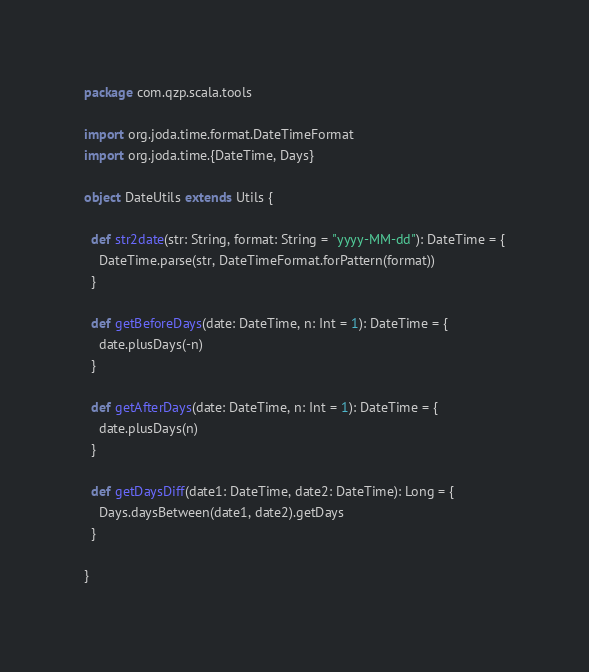Convert code to text. <code><loc_0><loc_0><loc_500><loc_500><_Scala_>package com.qzp.scala.tools

import org.joda.time.format.DateTimeFormat
import org.joda.time.{DateTime, Days}

object DateUtils extends Utils {

  def str2date(str: String, format: String = "yyyy-MM-dd"): DateTime = {
    DateTime.parse(str, DateTimeFormat.forPattern(format))
  }

  def getBeforeDays(date: DateTime, n: Int = 1): DateTime = {
    date.plusDays(-n)
  }

  def getAfterDays(date: DateTime, n: Int = 1): DateTime = {
    date.plusDays(n)
  }

  def getDaysDiff(date1: DateTime, date2: DateTime): Long = {
    Days.daysBetween(date1, date2).getDays
  }

}
</code> 